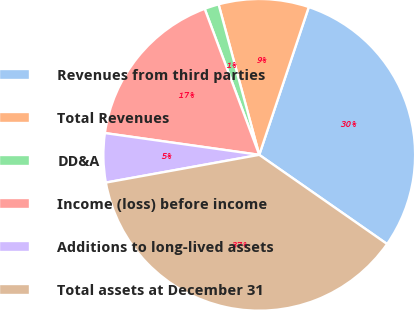Convert chart to OTSL. <chart><loc_0><loc_0><loc_500><loc_500><pie_chart><fcel>Revenues from third parties<fcel>Total Revenues<fcel>DD&A<fcel>Income (loss) before income<fcel>Additions to long-lived assets<fcel>Total assets at December 31<nl><fcel>29.55%<fcel>9.35%<fcel>1.49%<fcel>17.08%<fcel>5.08%<fcel>37.46%<nl></chart> 